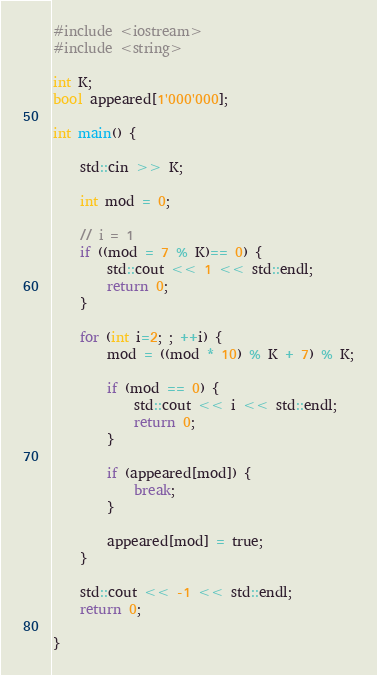<code> <loc_0><loc_0><loc_500><loc_500><_C++_>#include <iostream>
#include <string>

int K;
bool appeared[1'000'000];

int main() {

    std::cin >> K;

    int mod = 0;

    // i = 1
    if ((mod = 7 % K)== 0) {
        std::cout << 1 << std::endl;
        return 0;
    }

    for (int i=2; ; ++i) {
        mod = ((mod * 10) % K + 7) % K;

        if (mod == 0) {
            std::cout << i << std::endl;
            return 0;
        }

        if (appeared[mod]) {
            break;
        }

        appeared[mod] = true;
    }

    std::cout << -1 << std::endl;
    return 0;

}
</code> 